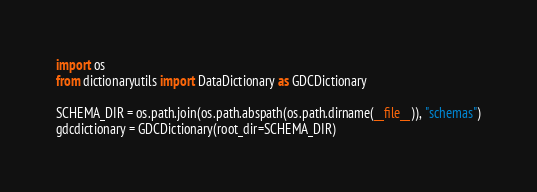<code> <loc_0><loc_0><loc_500><loc_500><_Python_>import os
from dictionaryutils import DataDictionary as GDCDictionary

SCHEMA_DIR = os.path.join(os.path.abspath(os.path.dirname(__file__)), "schemas")
gdcdictionary = GDCDictionary(root_dir=SCHEMA_DIR)</code> 